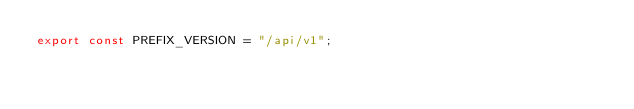Convert code to text. <code><loc_0><loc_0><loc_500><loc_500><_JavaScript_>export const PREFIX_VERSION = "/api/v1";
</code> 